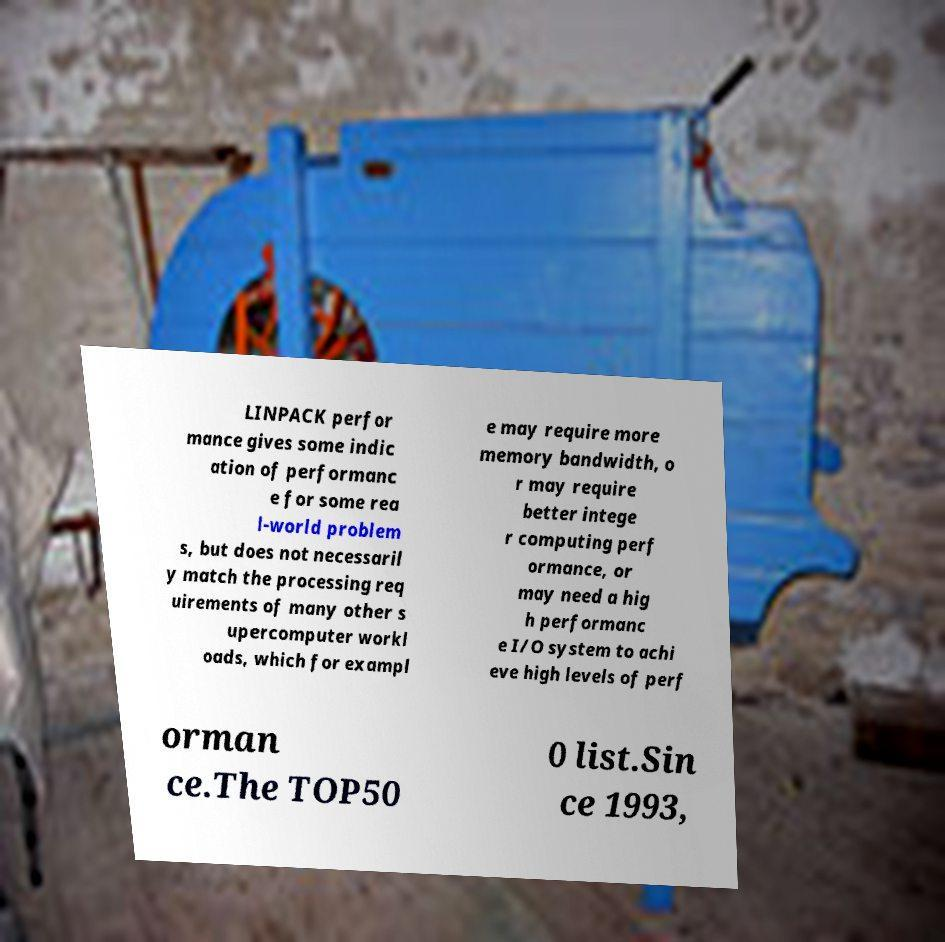Could you extract and type out the text from this image? LINPACK perfor mance gives some indic ation of performanc e for some rea l-world problem s, but does not necessaril y match the processing req uirements of many other s upercomputer workl oads, which for exampl e may require more memory bandwidth, o r may require better intege r computing perf ormance, or may need a hig h performanc e I/O system to achi eve high levels of perf orman ce.The TOP50 0 list.Sin ce 1993, 